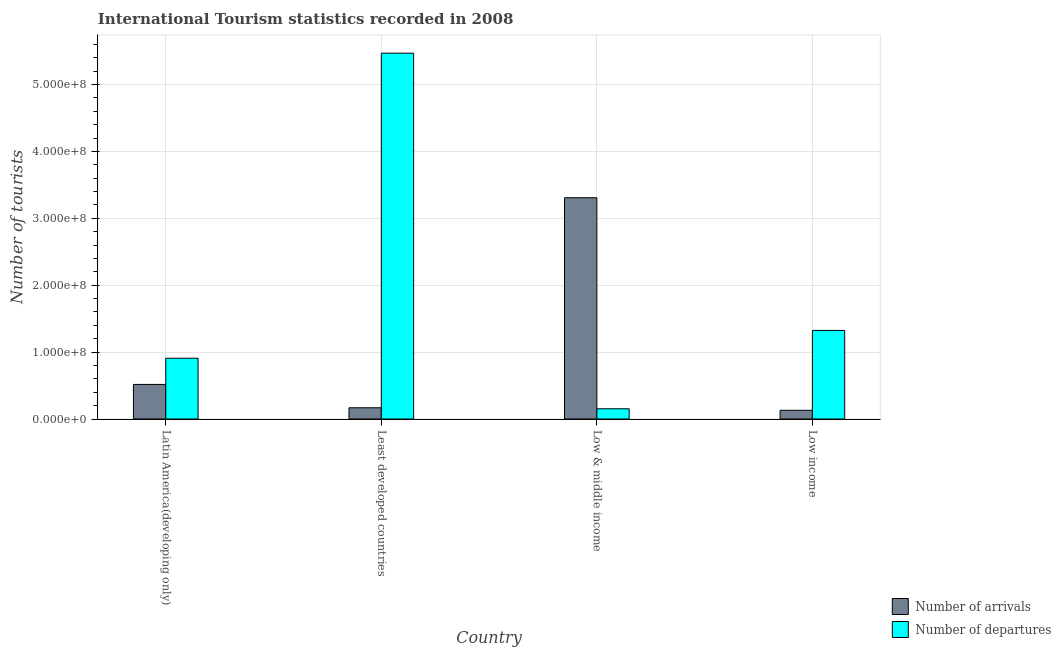How many different coloured bars are there?
Offer a terse response. 2. How many groups of bars are there?
Your answer should be compact. 4. Are the number of bars on each tick of the X-axis equal?
Ensure brevity in your answer.  Yes. How many bars are there on the 4th tick from the right?
Offer a terse response. 2. What is the label of the 4th group of bars from the left?
Your answer should be compact. Low income. What is the number of tourist departures in Least developed countries?
Give a very brief answer. 5.47e+08. Across all countries, what is the maximum number of tourist departures?
Give a very brief answer. 5.47e+08. Across all countries, what is the minimum number of tourist departures?
Keep it short and to the point. 1.53e+07. In which country was the number of tourist arrivals maximum?
Offer a very short reply. Low & middle income. In which country was the number of tourist departures minimum?
Make the answer very short. Low & middle income. What is the total number of tourist departures in the graph?
Your response must be concise. 7.86e+08. What is the difference between the number of tourist departures in Latin America(developing only) and that in Low & middle income?
Offer a terse response. 7.56e+07. What is the difference between the number of tourist arrivals in Latin America(developing only) and the number of tourist departures in Least developed countries?
Offer a terse response. -4.95e+08. What is the average number of tourist departures per country?
Keep it short and to the point. 1.96e+08. What is the difference between the number of tourist arrivals and number of tourist departures in Latin America(developing only)?
Your response must be concise. -3.92e+07. What is the ratio of the number of tourist arrivals in Latin America(developing only) to that in Low income?
Your response must be concise. 3.97. What is the difference between the highest and the second highest number of tourist departures?
Offer a very short reply. 4.14e+08. What is the difference between the highest and the lowest number of tourist arrivals?
Your response must be concise. 3.18e+08. Is the sum of the number of tourist departures in Least developed countries and Low income greater than the maximum number of tourist arrivals across all countries?
Provide a short and direct response. Yes. What does the 1st bar from the left in Low & middle income represents?
Provide a short and direct response. Number of arrivals. What does the 1st bar from the right in Latin America(developing only) represents?
Make the answer very short. Number of departures. How many bars are there?
Provide a succinct answer. 8. Does the graph contain grids?
Offer a terse response. Yes. Where does the legend appear in the graph?
Offer a very short reply. Bottom right. How many legend labels are there?
Your answer should be very brief. 2. What is the title of the graph?
Ensure brevity in your answer.  International Tourism statistics recorded in 2008. Does "Male entrants" appear as one of the legend labels in the graph?
Your answer should be very brief. No. What is the label or title of the Y-axis?
Offer a very short reply. Number of tourists. What is the Number of tourists in Number of arrivals in Latin America(developing only)?
Your answer should be very brief. 5.17e+07. What is the Number of tourists of Number of departures in Latin America(developing only)?
Keep it short and to the point. 9.09e+07. What is the Number of tourists in Number of arrivals in Least developed countries?
Ensure brevity in your answer.  1.68e+07. What is the Number of tourists in Number of departures in Least developed countries?
Your answer should be very brief. 5.47e+08. What is the Number of tourists in Number of arrivals in Low & middle income?
Ensure brevity in your answer.  3.31e+08. What is the Number of tourists of Number of departures in Low & middle income?
Provide a succinct answer. 1.53e+07. What is the Number of tourists in Number of arrivals in Low income?
Provide a short and direct response. 1.30e+07. What is the Number of tourists in Number of departures in Low income?
Your answer should be compact. 1.32e+08. Across all countries, what is the maximum Number of tourists in Number of arrivals?
Keep it short and to the point. 3.31e+08. Across all countries, what is the maximum Number of tourists in Number of departures?
Ensure brevity in your answer.  5.47e+08. Across all countries, what is the minimum Number of tourists in Number of arrivals?
Your answer should be very brief. 1.30e+07. Across all countries, what is the minimum Number of tourists of Number of departures?
Offer a terse response. 1.53e+07. What is the total Number of tourists in Number of arrivals in the graph?
Keep it short and to the point. 4.12e+08. What is the total Number of tourists of Number of departures in the graph?
Provide a succinct answer. 7.86e+08. What is the difference between the Number of tourists of Number of arrivals in Latin America(developing only) and that in Least developed countries?
Offer a terse response. 3.49e+07. What is the difference between the Number of tourists of Number of departures in Latin America(developing only) and that in Least developed countries?
Provide a succinct answer. -4.56e+08. What is the difference between the Number of tourists of Number of arrivals in Latin America(developing only) and that in Low & middle income?
Offer a terse response. -2.79e+08. What is the difference between the Number of tourists of Number of departures in Latin America(developing only) and that in Low & middle income?
Keep it short and to the point. 7.56e+07. What is the difference between the Number of tourists of Number of arrivals in Latin America(developing only) and that in Low income?
Your answer should be very brief. 3.87e+07. What is the difference between the Number of tourists in Number of departures in Latin America(developing only) and that in Low income?
Your answer should be compact. -4.15e+07. What is the difference between the Number of tourists of Number of arrivals in Least developed countries and that in Low & middle income?
Ensure brevity in your answer.  -3.14e+08. What is the difference between the Number of tourists in Number of departures in Least developed countries and that in Low & middle income?
Your answer should be compact. 5.32e+08. What is the difference between the Number of tourists in Number of arrivals in Least developed countries and that in Low income?
Your answer should be compact. 3.77e+06. What is the difference between the Number of tourists of Number of departures in Least developed countries and that in Low income?
Make the answer very short. 4.14e+08. What is the difference between the Number of tourists of Number of arrivals in Low & middle income and that in Low income?
Provide a succinct answer. 3.18e+08. What is the difference between the Number of tourists of Number of departures in Low & middle income and that in Low income?
Provide a short and direct response. -1.17e+08. What is the difference between the Number of tourists of Number of arrivals in Latin America(developing only) and the Number of tourists of Number of departures in Least developed countries?
Your answer should be compact. -4.95e+08. What is the difference between the Number of tourists in Number of arrivals in Latin America(developing only) and the Number of tourists in Number of departures in Low & middle income?
Give a very brief answer. 3.64e+07. What is the difference between the Number of tourists of Number of arrivals in Latin America(developing only) and the Number of tourists of Number of departures in Low income?
Provide a short and direct response. -8.07e+07. What is the difference between the Number of tourists in Number of arrivals in Least developed countries and the Number of tourists in Number of departures in Low & middle income?
Make the answer very short. 1.49e+06. What is the difference between the Number of tourists in Number of arrivals in Least developed countries and the Number of tourists in Number of departures in Low income?
Provide a short and direct response. -1.16e+08. What is the difference between the Number of tourists in Number of arrivals in Low & middle income and the Number of tourists in Number of departures in Low income?
Your answer should be very brief. 1.98e+08. What is the average Number of tourists in Number of arrivals per country?
Provide a succinct answer. 1.03e+08. What is the average Number of tourists of Number of departures per country?
Ensure brevity in your answer.  1.96e+08. What is the difference between the Number of tourists of Number of arrivals and Number of tourists of Number of departures in Latin America(developing only)?
Provide a succinct answer. -3.92e+07. What is the difference between the Number of tourists in Number of arrivals and Number of tourists in Number of departures in Least developed countries?
Keep it short and to the point. -5.30e+08. What is the difference between the Number of tourists in Number of arrivals and Number of tourists in Number of departures in Low & middle income?
Make the answer very short. 3.16e+08. What is the difference between the Number of tourists of Number of arrivals and Number of tourists of Number of departures in Low income?
Offer a terse response. -1.19e+08. What is the ratio of the Number of tourists of Number of arrivals in Latin America(developing only) to that in Least developed countries?
Provide a succinct answer. 3.08. What is the ratio of the Number of tourists in Number of departures in Latin America(developing only) to that in Least developed countries?
Provide a succinct answer. 0.17. What is the ratio of the Number of tourists in Number of arrivals in Latin America(developing only) to that in Low & middle income?
Provide a succinct answer. 0.16. What is the ratio of the Number of tourists of Number of departures in Latin America(developing only) to that in Low & middle income?
Your answer should be very brief. 5.94. What is the ratio of the Number of tourists in Number of arrivals in Latin America(developing only) to that in Low income?
Give a very brief answer. 3.97. What is the ratio of the Number of tourists of Number of departures in Latin America(developing only) to that in Low income?
Offer a very short reply. 0.69. What is the ratio of the Number of tourists of Number of arrivals in Least developed countries to that in Low & middle income?
Offer a terse response. 0.05. What is the ratio of the Number of tourists in Number of departures in Least developed countries to that in Low & middle income?
Your answer should be very brief. 35.74. What is the ratio of the Number of tourists of Number of arrivals in Least developed countries to that in Low income?
Your response must be concise. 1.29. What is the ratio of the Number of tourists in Number of departures in Least developed countries to that in Low income?
Keep it short and to the point. 4.13. What is the ratio of the Number of tourists of Number of arrivals in Low & middle income to that in Low income?
Your response must be concise. 25.4. What is the ratio of the Number of tourists in Number of departures in Low & middle income to that in Low income?
Offer a very short reply. 0.12. What is the difference between the highest and the second highest Number of tourists of Number of arrivals?
Offer a terse response. 2.79e+08. What is the difference between the highest and the second highest Number of tourists of Number of departures?
Provide a short and direct response. 4.14e+08. What is the difference between the highest and the lowest Number of tourists in Number of arrivals?
Provide a succinct answer. 3.18e+08. What is the difference between the highest and the lowest Number of tourists in Number of departures?
Your response must be concise. 5.32e+08. 